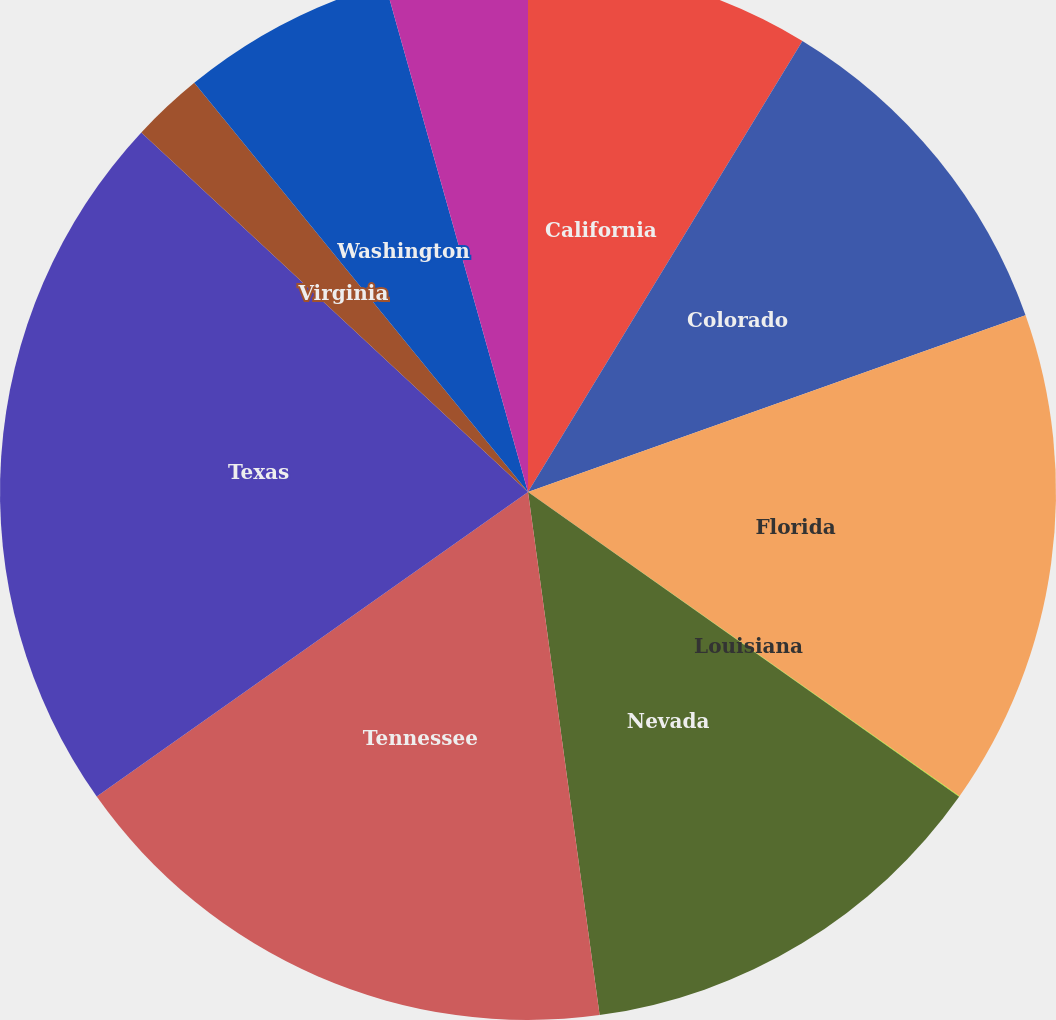Convert chart. <chart><loc_0><loc_0><loc_500><loc_500><pie_chart><fcel>California<fcel>Colorado<fcel>Florida<fcel>Louisiana<fcel>Nevada<fcel>Tennessee<fcel>Texas<fcel>Virginia<fcel>Washington<fcel>West Virginia<nl><fcel>8.7%<fcel>10.87%<fcel>15.21%<fcel>0.02%<fcel>13.04%<fcel>17.38%<fcel>21.71%<fcel>2.19%<fcel>6.53%<fcel>4.36%<nl></chart> 